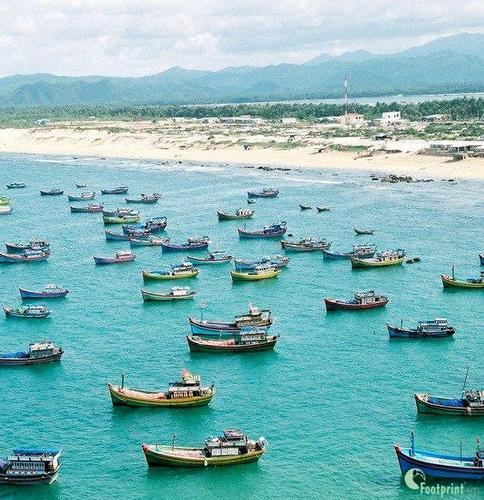How many boats are featured in the image? There are several boats in the image, but an exact count cannot be determined from the given information. Determine the emotions or sentiments conveyed by the image. The image conveys a peaceful and serene sentiment with boats on calm water and a beautiful beach landscape. List three objects or features associated with the beach. White sand, grass, and seaweed on the shore. Create a narrative description of the scene blending some of the objects in the image. On a tranquil shoreline, boats rest gently on the calm water, while buildings and trees line the white sandy beach. In the distance, majestic mountains create a serene backdrop for this picturesque landscape. Estimate the overall image quality based on the given information. The overall image quality might be considered good, as it provides detailed information about various objects in the scene. Which objects in the image are interacting with one another? The boats are interacting with the water, and the waves are interacting with the shore. Provide a caption that describes the overall scene in the image. Fishing boats anchored along a tranquil shoreline, with mountains and trees in the background. Are there any objects that appear to be elevated in the image? If so, describe them. Mountains in the background and a satellite in the sky seem elevated in the image. Identify and describe the main colors present in the image. The main colors in the image are blue-green for the water, white for the sand, and various shades of green and brown for the landscape. Can you describe the shore marker present on the beach? The shore marker is a tall pole that appears to be red and white in color. How are the boats in the image positioned in relation to the shore? Boats are in shallow water near the shore. Evaluate the quality of the image. The image quality is moderately high. Find the lighthouse standing tall on a cliff to the left of the beach, guiding ships safely at night. No, it's not mentioned in the image. Which object in the image is furthest away from the sand? Boats are furthest away from the sand. Do you see the large, red umbrella near the shore? It is providing shade for a family enjoying a picnic on the beach. This instruction is misleading because there is no mention of an umbrella, family, or picnic in the image information. The focus is on the boats, beach, water, and surrounding landscape, not on people or their belongings. List all the objects found in the image. Boats, beach, water, waves, trees, buildings, mountains, seaweed, sand, pole, clouds, satellite, and writing. Do you notice the snow-capped mountain peaks in the distant background, contrasting with the warm sand and water in the foreground? This instruction is misleading because there are mentions of mountains in the background, but none of them are described as snow-capped. The image information focuses on beach, water, and the surrounding elements including mountains, but not specifically snow-covered ones. Determine which object is responsible for providing credit to the image. Writing, located at X:390 Y:466 Width:93 Height:93. Estimate the visual quality of the image. The visual quality of the image is good. What color is the sky in the image? The sky is blue in color. State the emotions associated with the image. Calmness and tranquility. Tell me the position and size of the white sand beach. X:4 Y:113 Width:477 Height:477 Describe the sentiment of the image. The image has a calm and serene sentiment. Classify the elements in the image by their attributes. Boats (brown), sky (blue), water (calm), and beach (white sand). Provide a short image caption. Boats on calm water near a white sand beach with mountains in the background. Identify any text present in the image. There is a writing in the image. Can you find the airplane flying high in the sky? It's leaving a trail of white smoke behind it. This instruction is misleading because there is no mention of an airplane or smoke trail in the provided image information. The focus is on boats, water, beach, and other related objects, not on an airplane in the sky. Can you locate the position of the red and white signal tower? X:336 Y:68 Width:20 Height:20 Analyze the image for unusual content. No unusual content detected in the image. Can you spot the school of colorful fish swimming near the boats in the shallow water, creating a beautiful pattern with their movement? This instruction is misleading because there are no mentions of fish or their colors in the image information. The focus is on boats, water, the beach, and the surrounding landscape, not on marine life. Examine the interactions between objects in the image. Boats are floating in shallow water near the shore, while buildings and trees are located behind the beach area. What is the color of the boat in the image? The boat is brown in color. Form a set of words to portray the image. Serene, boats, beach, mountains, calm water, clear sky. Decode any words in the image. There is a writing in the image, but the content is unclear. Find any anomalies in the image. No major anomalies detected in the image. 